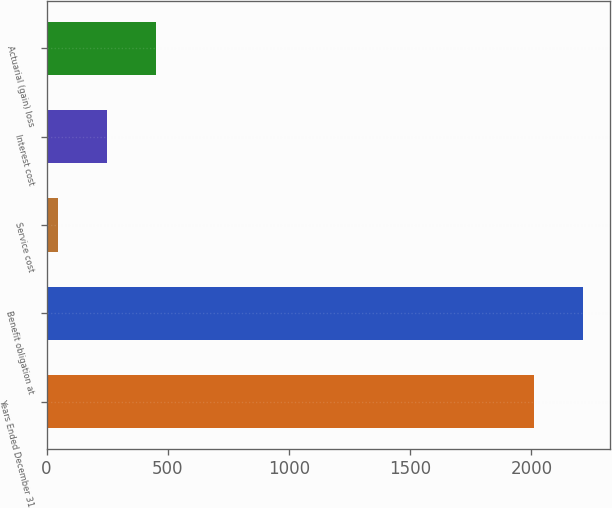Convert chart to OTSL. <chart><loc_0><loc_0><loc_500><loc_500><bar_chart><fcel>Years Ended December 31<fcel>Benefit obligation at<fcel>Service cost<fcel>Interest cost<fcel>Actuarial (gain) loss<nl><fcel>2012<fcel>2214.4<fcel>48<fcel>250.4<fcel>452.8<nl></chart> 